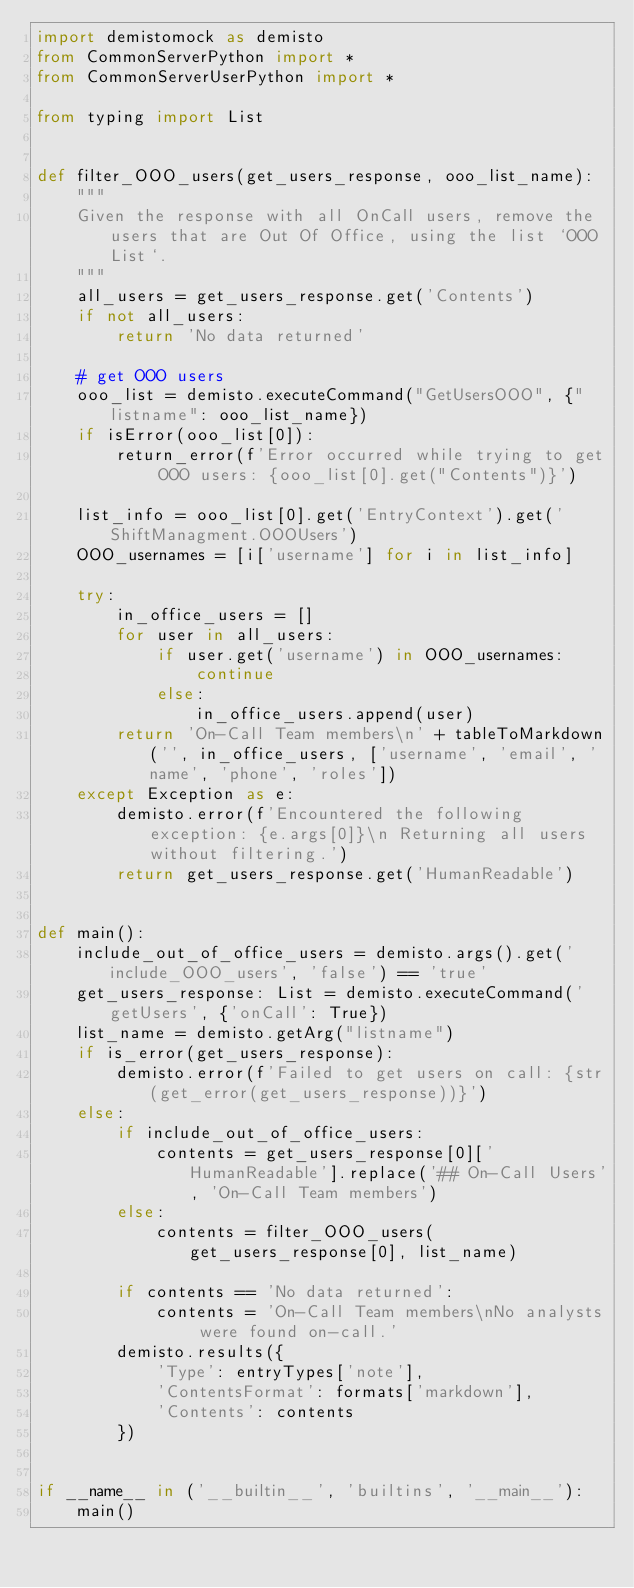Convert code to text. <code><loc_0><loc_0><loc_500><loc_500><_Python_>import demistomock as demisto
from CommonServerPython import *
from CommonServerUserPython import *

from typing import List


def filter_OOO_users(get_users_response, ooo_list_name):
    """
    Given the response with all OnCall users, remove the users that are Out Of Office, using the list `OOO List`.
    """
    all_users = get_users_response.get('Contents')
    if not all_users:
        return 'No data returned'

    # get OOO users
    ooo_list = demisto.executeCommand("GetUsersOOO", {"listname": ooo_list_name})
    if isError(ooo_list[0]):
        return_error(f'Error occurred while trying to get OOO users: {ooo_list[0].get("Contents")}')

    list_info = ooo_list[0].get('EntryContext').get('ShiftManagment.OOOUsers')
    OOO_usernames = [i['username'] for i in list_info]

    try:
        in_office_users = []
        for user in all_users:
            if user.get('username') in OOO_usernames:
                continue
            else:
                in_office_users.append(user)
        return 'On-Call Team members\n' + tableToMarkdown('', in_office_users, ['username', 'email', 'name', 'phone', 'roles'])
    except Exception as e:
        demisto.error(f'Encountered the following exception: {e.args[0]}\n Returning all users without filtering.')
        return get_users_response.get('HumanReadable')


def main():
    include_out_of_office_users = demisto.args().get('include_OOO_users', 'false') == 'true'
    get_users_response: List = demisto.executeCommand('getUsers', {'onCall': True})
    list_name = demisto.getArg("listname")
    if is_error(get_users_response):
        demisto.error(f'Failed to get users on call: {str(get_error(get_users_response))}')
    else:
        if include_out_of_office_users:
            contents = get_users_response[0]['HumanReadable'].replace('## On-Call Users', 'On-Call Team members')
        else:
            contents = filter_OOO_users(get_users_response[0], list_name)

        if contents == 'No data returned':
            contents = 'On-Call Team members\nNo analysts were found on-call.'
        demisto.results({
            'Type': entryTypes['note'],
            'ContentsFormat': formats['markdown'],
            'Contents': contents
        })


if __name__ in ('__builtin__', 'builtins', '__main__'):
    main()
</code> 